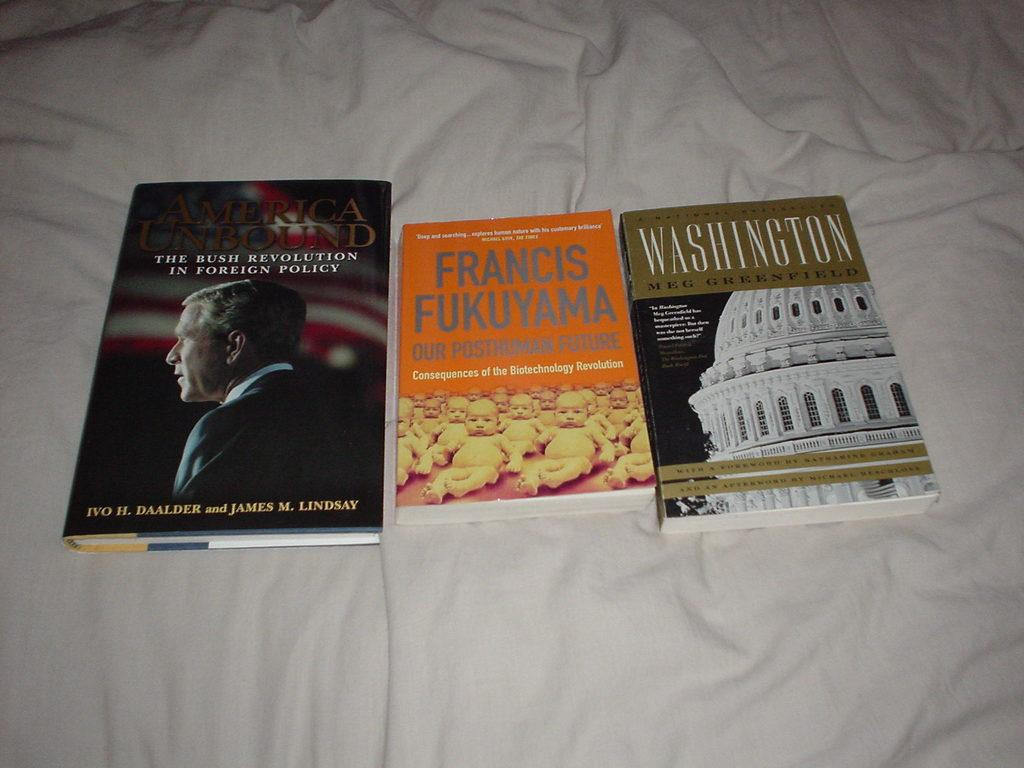<image>
Describe the image concisely. the word Francis is on a book on a bed 